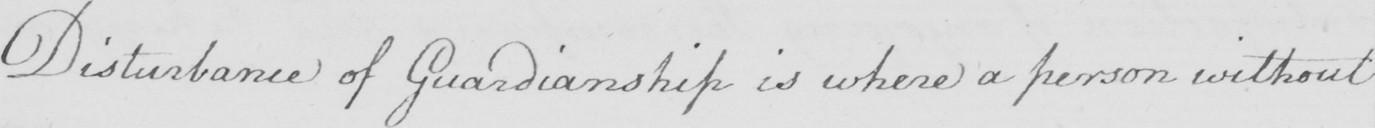Please transcribe the handwritten text in this image. Disturbance of Guardianship is where a person without 